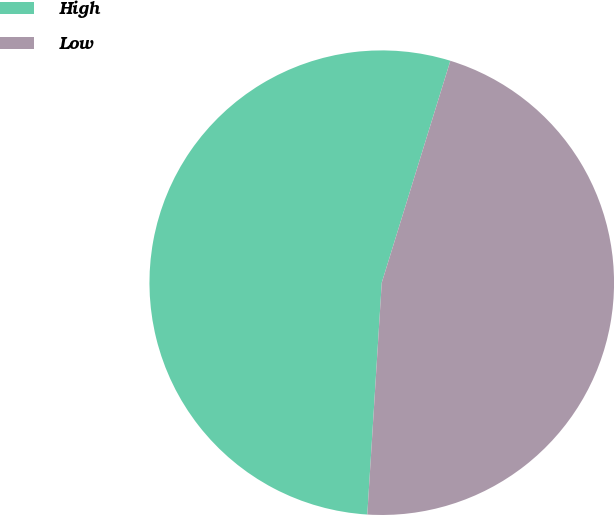Convert chart to OTSL. <chart><loc_0><loc_0><loc_500><loc_500><pie_chart><fcel>High<fcel>Low<nl><fcel>53.78%<fcel>46.22%<nl></chart> 